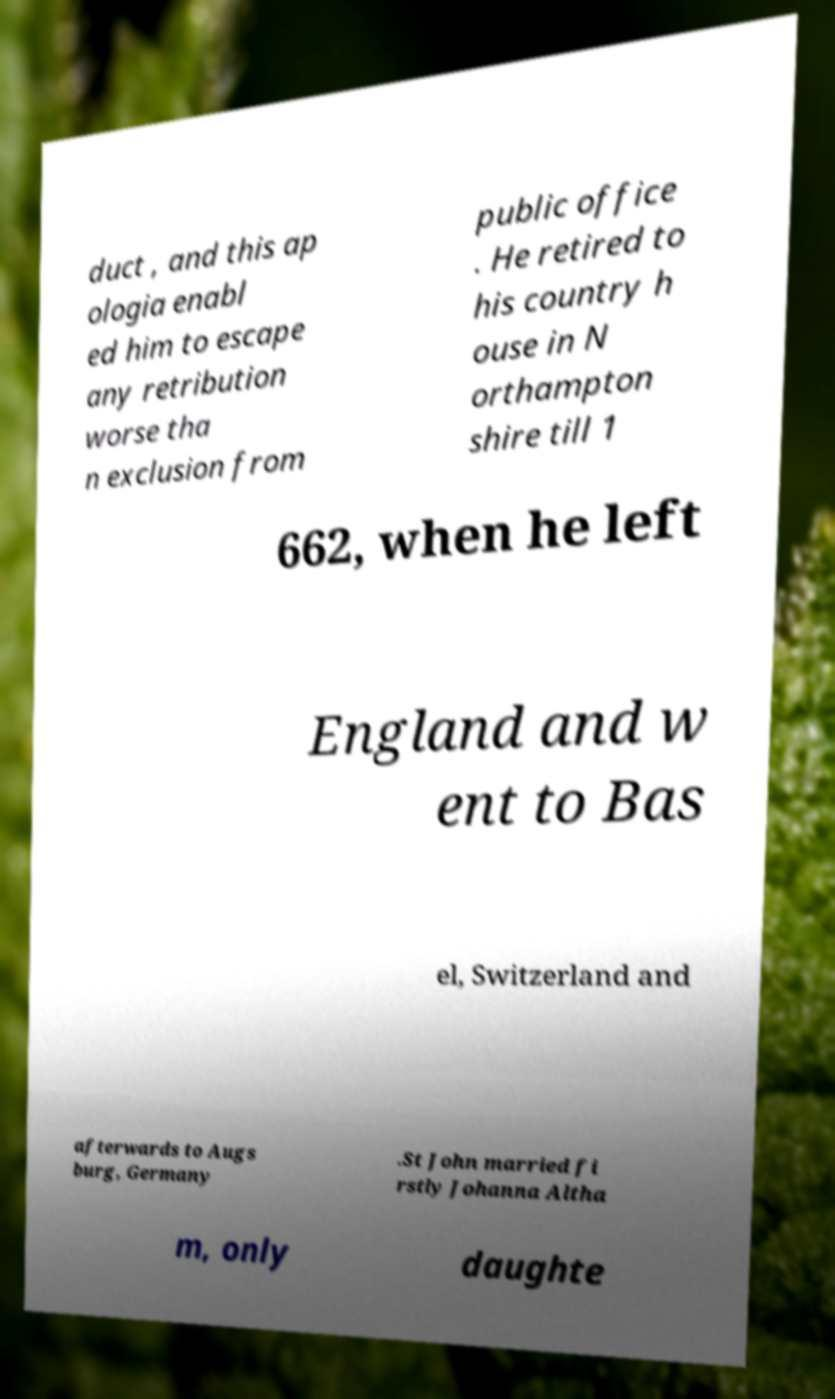Could you assist in decoding the text presented in this image and type it out clearly? duct , and this ap ologia enabl ed him to escape any retribution worse tha n exclusion from public office . He retired to his country h ouse in N orthampton shire till 1 662, when he left England and w ent to Bas el, Switzerland and afterwards to Augs burg, Germany .St John married fi rstly Johanna Altha m, only daughte 